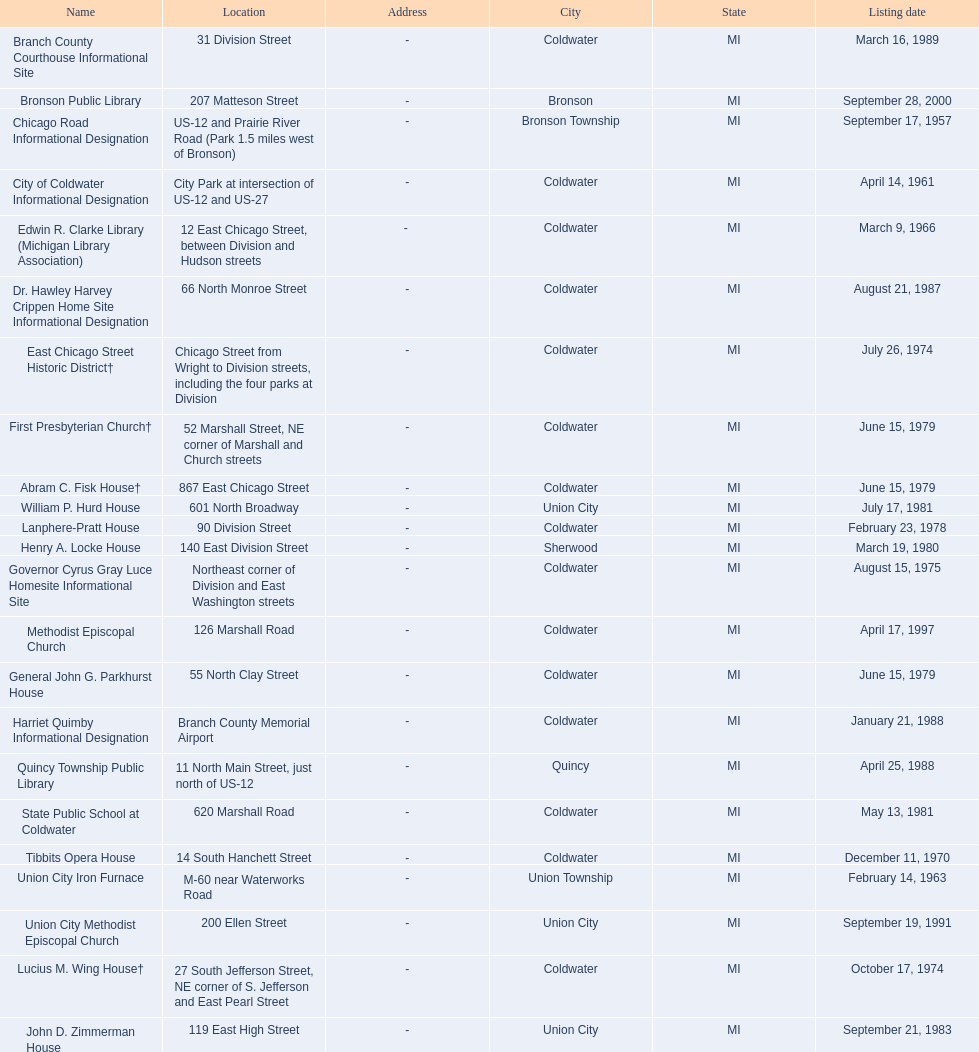How many sites were listed as historical before 1980? 12. 